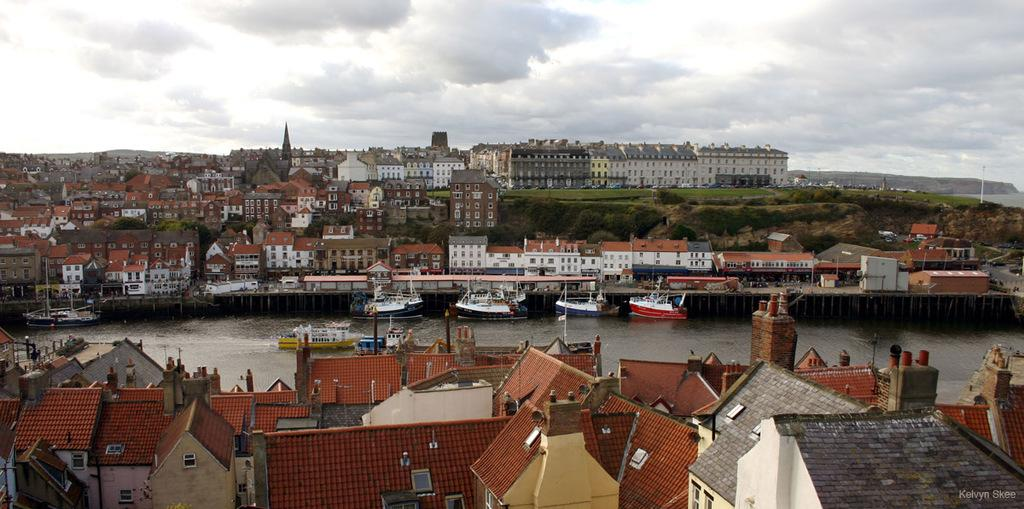What type of structures can be seen in the image? There are buildings in the image. What is floating on the water in the image? There are boats floating on water in the image. What can be seen in the sky in the image? There are clouds in the sky in the image. What type of canvas is being used for the game in the image? There is no canvas or game present in the image; it features buildings, boats, and clouds. How many bikes can be seen in the image? There are no bikes present in the image. 